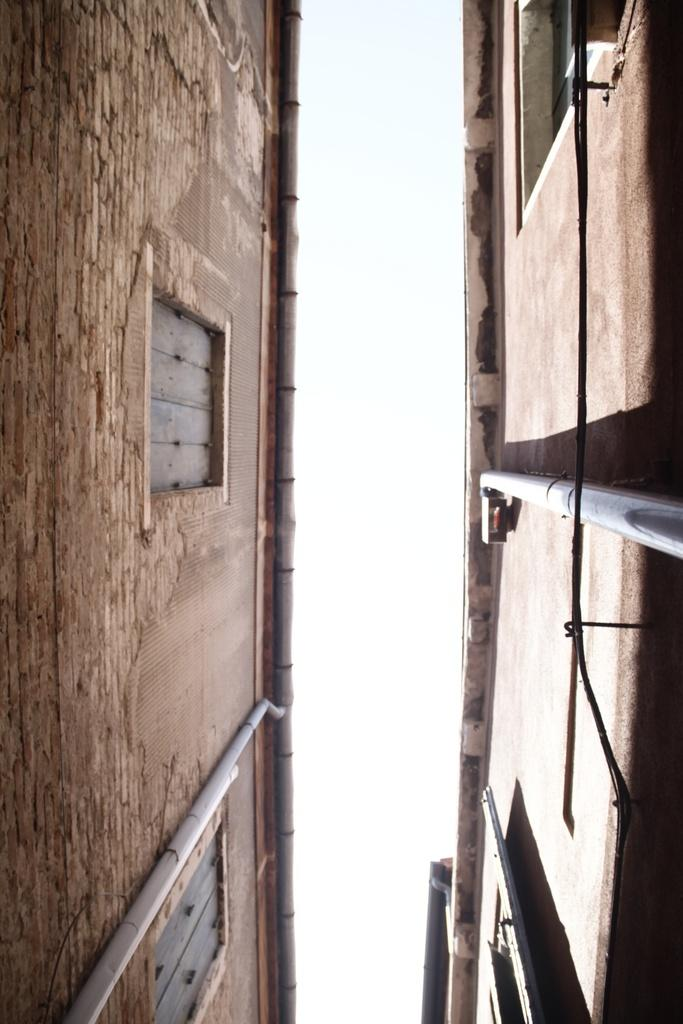What type of structures are visible in the image? There are building walls in the image. What architectural features can be seen on the building walls? There are windows in the image. Are there any other elements visible on the building walls? Yes, there are pipes in the image. What can be seen in the background of the image? The sky is visible in the image. What type of toothpaste is being used to clean the pipes in the image? There is no toothpaste present in the image, nor is there any indication of cleaning or maintenance being performed on the pipes. 